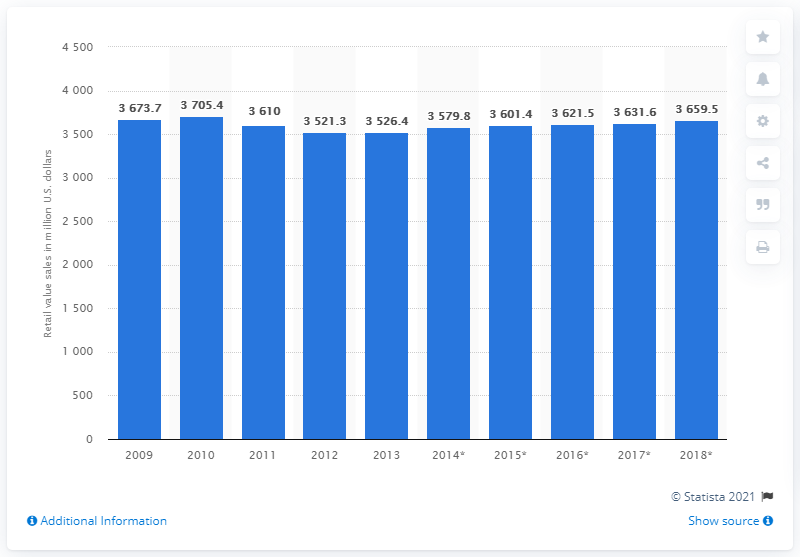Draw attention to some important aspects in this diagram. The retail sales value of yogurt and sour milk products is expected to increase by 2018 to a total of 3705.4 dollars. In 2013, the retail sales value of yogurt and sour milk products was 3526.4 million dollars. 